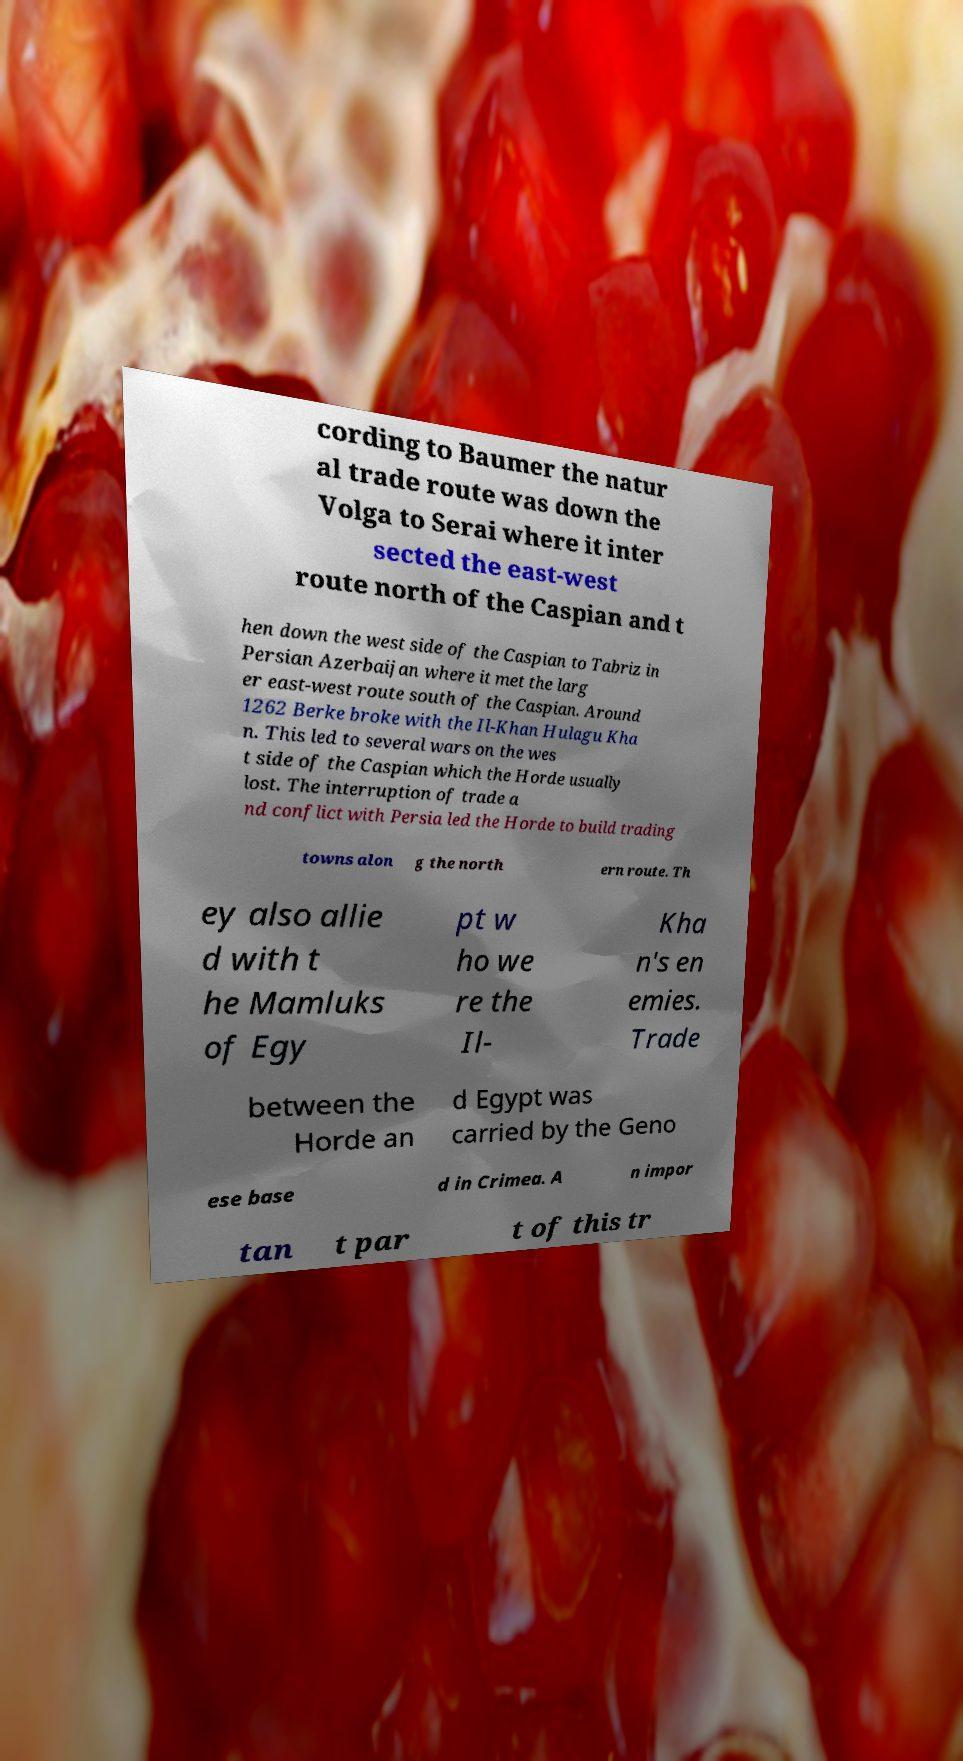For documentation purposes, I need the text within this image transcribed. Could you provide that? cording to Baumer the natur al trade route was down the Volga to Serai where it inter sected the east-west route north of the Caspian and t hen down the west side of the Caspian to Tabriz in Persian Azerbaijan where it met the larg er east-west route south of the Caspian. Around 1262 Berke broke with the Il-Khan Hulagu Kha n. This led to several wars on the wes t side of the Caspian which the Horde usually lost. The interruption of trade a nd conflict with Persia led the Horde to build trading towns alon g the north ern route. Th ey also allie d with t he Mamluks of Egy pt w ho we re the Il- Kha n's en emies. Trade between the Horde an d Egypt was carried by the Geno ese base d in Crimea. A n impor tan t par t of this tr 